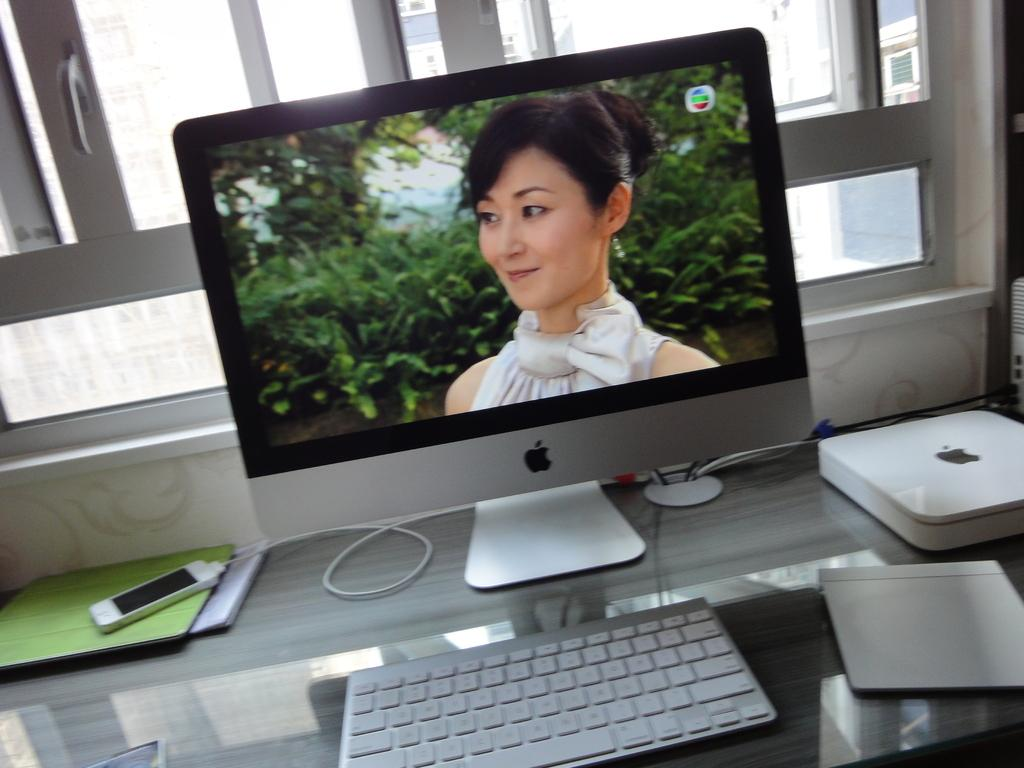What electronic device is on the table in the image? There is a computer on the table in the image. What is displayed on the computer monitor? A woman's photo is displayed on the computer monitor. What is used for typing on the computer? There is a keyboard on the table for typing on the computer. What other electronic device is on the table? There is a mobile on the table. What can be seen in the background of the image? There is a window in the background. How long does it take for the trail to form in the image? There is no trail present in the image. What type of home is visible in the background of the image? There is no home visible in the image; only a window can be seen in the background. 